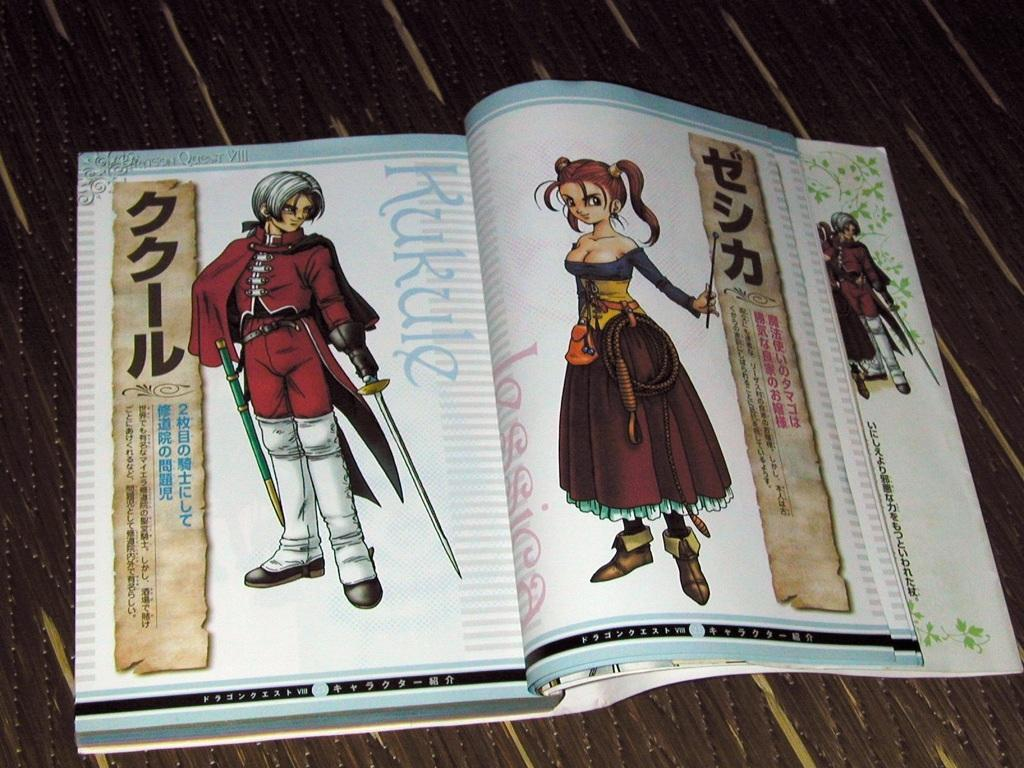<image>
Relay a brief, clear account of the picture shown. Characters for Japanese animation are shown in a book, one is named Kukule. 